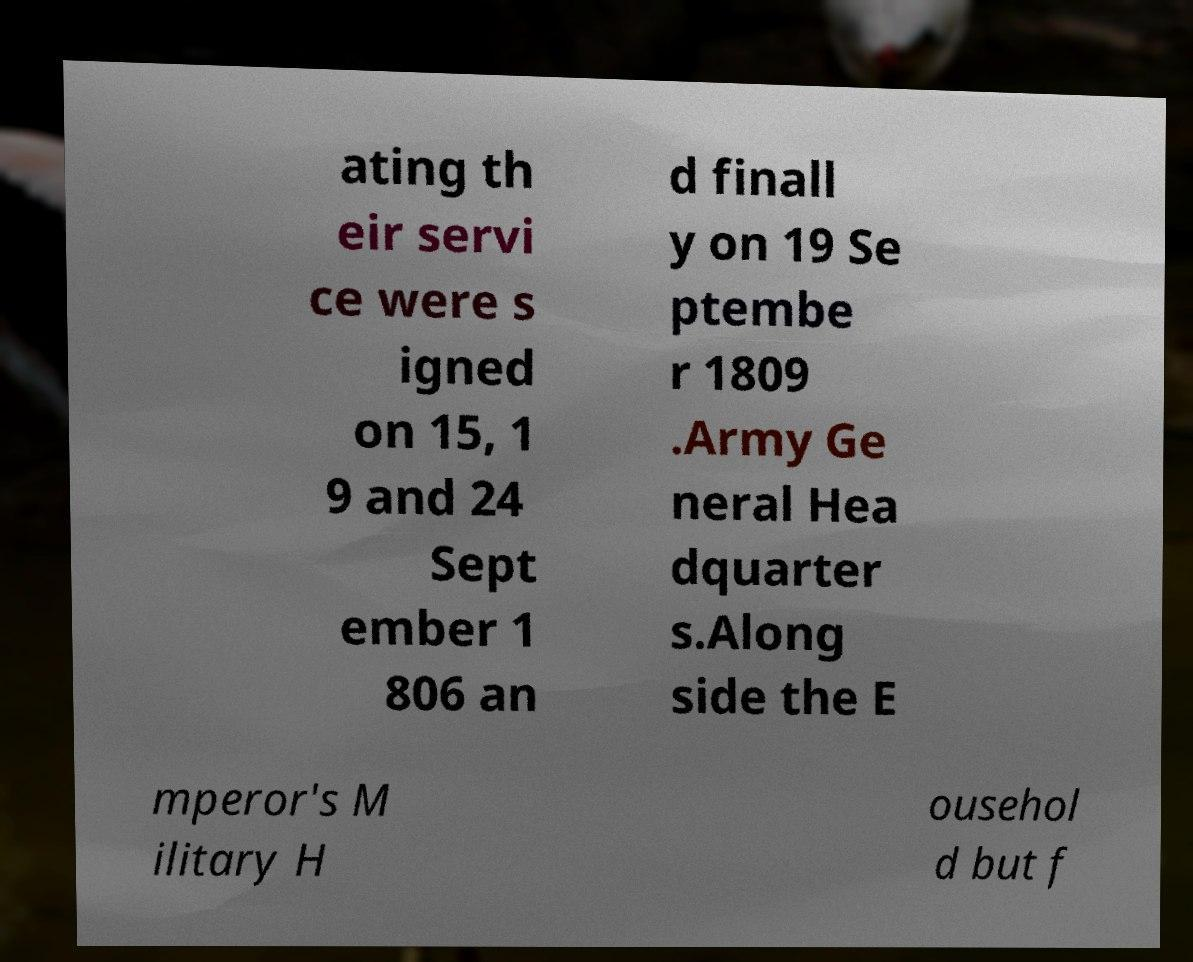Could you assist in decoding the text presented in this image and type it out clearly? ating th eir servi ce were s igned on 15, 1 9 and 24 Sept ember 1 806 an d finall y on 19 Se ptembe r 1809 .Army Ge neral Hea dquarter s.Along side the E mperor's M ilitary H ousehol d but f 